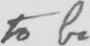Please provide the text content of this handwritten line. to be 